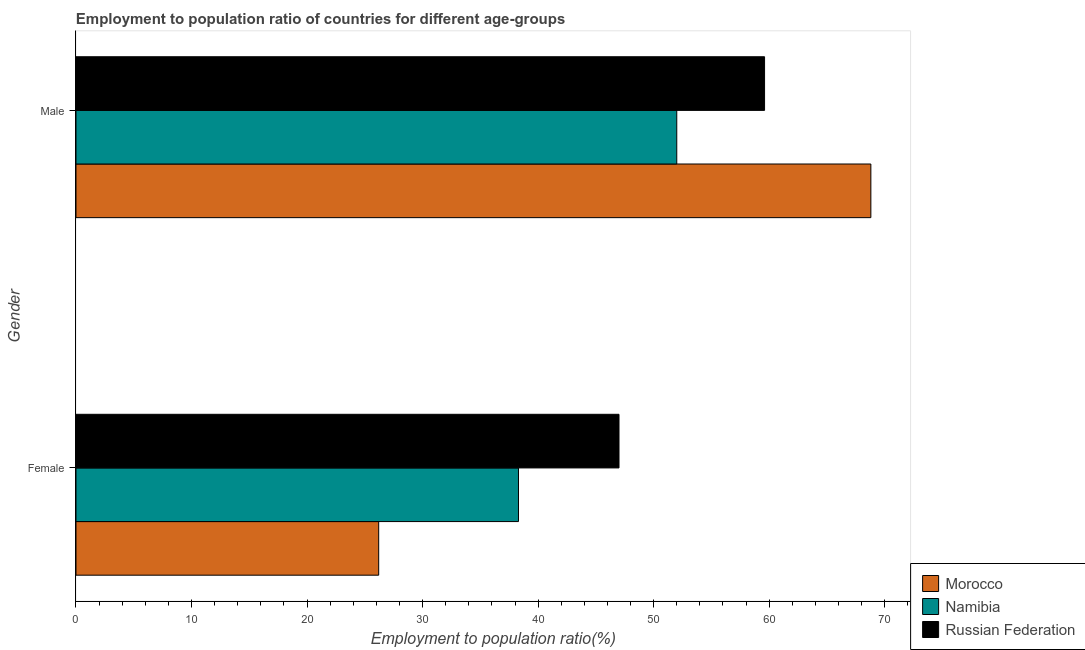How many different coloured bars are there?
Make the answer very short. 3. How many groups of bars are there?
Your answer should be very brief. 2. Are the number of bars per tick equal to the number of legend labels?
Keep it short and to the point. Yes. How many bars are there on the 1st tick from the top?
Provide a short and direct response. 3. How many bars are there on the 1st tick from the bottom?
Keep it short and to the point. 3. Across all countries, what is the maximum employment to population ratio(male)?
Make the answer very short. 68.8. Across all countries, what is the minimum employment to population ratio(female)?
Provide a succinct answer. 26.2. In which country was the employment to population ratio(female) maximum?
Make the answer very short. Russian Federation. In which country was the employment to population ratio(female) minimum?
Offer a terse response. Morocco. What is the total employment to population ratio(male) in the graph?
Provide a short and direct response. 180.4. What is the difference between the employment to population ratio(male) in Russian Federation and that in Namibia?
Make the answer very short. 7.6. What is the difference between the employment to population ratio(female) in Morocco and the employment to population ratio(male) in Russian Federation?
Provide a succinct answer. -33.4. What is the average employment to population ratio(female) per country?
Your response must be concise. 37.17. What is the difference between the employment to population ratio(female) and employment to population ratio(male) in Morocco?
Offer a terse response. -42.6. In how many countries, is the employment to population ratio(male) greater than 32 %?
Keep it short and to the point. 3. What is the ratio of the employment to population ratio(female) in Morocco to that in Namibia?
Offer a very short reply. 0.68. Is the employment to population ratio(female) in Russian Federation less than that in Morocco?
Offer a terse response. No. What does the 1st bar from the top in Female represents?
Your answer should be very brief. Russian Federation. What does the 1st bar from the bottom in Female represents?
Your response must be concise. Morocco. How many countries are there in the graph?
Keep it short and to the point. 3. What is the difference between two consecutive major ticks on the X-axis?
Keep it short and to the point. 10. How are the legend labels stacked?
Make the answer very short. Vertical. What is the title of the graph?
Provide a succinct answer. Employment to population ratio of countries for different age-groups. Does "Nepal" appear as one of the legend labels in the graph?
Make the answer very short. No. What is the Employment to population ratio(%) of Morocco in Female?
Ensure brevity in your answer.  26.2. What is the Employment to population ratio(%) in Namibia in Female?
Your response must be concise. 38.3. What is the Employment to population ratio(%) in Russian Federation in Female?
Ensure brevity in your answer.  47. What is the Employment to population ratio(%) of Morocco in Male?
Provide a succinct answer. 68.8. What is the Employment to population ratio(%) in Russian Federation in Male?
Your answer should be very brief. 59.6. Across all Gender, what is the maximum Employment to population ratio(%) in Morocco?
Your answer should be compact. 68.8. Across all Gender, what is the maximum Employment to population ratio(%) of Russian Federation?
Your answer should be compact. 59.6. Across all Gender, what is the minimum Employment to population ratio(%) in Morocco?
Your answer should be compact. 26.2. Across all Gender, what is the minimum Employment to population ratio(%) in Namibia?
Provide a succinct answer. 38.3. What is the total Employment to population ratio(%) in Morocco in the graph?
Your answer should be compact. 95. What is the total Employment to population ratio(%) in Namibia in the graph?
Offer a very short reply. 90.3. What is the total Employment to population ratio(%) of Russian Federation in the graph?
Provide a short and direct response. 106.6. What is the difference between the Employment to population ratio(%) of Morocco in Female and that in Male?
Your response must be concise. -42.6. What is the difference between the Employment to population ratio(%) in Namibia in Female and that in Male?
Offer a terse response. -13.7. What is the difference between the Employment to population ratio(%) in Russian Federation in Female and that in Male?
Make the answer very short. -12.6. What is the difference between the Employment to population ratio(%) of Morocco in Female and the Employment to population ratio(%) of Namibia in Male?
Give a very brief answer. -25.8. What is the difference between the Employment to population ratio(%) of Morocco in Female and the Employment to population ratio(%) of Russian Federation in Male?
Ensure brevity in your answer.  -33.4. What is the difference between the Employment to population ratio(%) in Namibia in Female and the Employment to population ratio(%) in Russian Federation in Male?
Provide a short and direct response. -21.3. What is the average Employment to population ratio(%) of Morocco per Gender?
Make the answer very short. 47.5. What is the average Employment to population ratio(%) of Namibia per Gender?
Give a very brief answer. 45.15. What is the average Employment to population ratio(%) in Russian Federation per Gender?
Ensure brevity in your answer.  53.3. What is the difference between the Employment to population ratio(%) of Morocco and Employment to population ratio(%) of Namibia in Female?
Offer a very short reply. -12.1. What is the difference between the Employment to population ratio(%) in Morocco and Employment to population ratio(%) in Russian Federation in Female?
Give a very brief answer. -20.8. What is the difference between the Employment to population ratio(%) of Namibia and Employment to population ratio(%) of Russian Federation in Female?
Your response must be concise. -8.7. What is the difference between the Employment to population ratio(%) in Morocco and Employment to population ratio(%) in Namibia in Male?
Provide a succinct answer. 16.8. What is the ratio of the Employment to population ratio(%) in Morocco in Female to that in Male?
Make the answer very short. 0.38. What is the ratio of the Employment to population ratio(%) in Namibia in Female to that in Male?
Your response must be concise. 0.74. What is the ratio of the Employment to population ratio(%) of Russian Federation in Female to that in Male?
Provide a short and direct response. 0.79. What is the difference between the highest and the second highest Employment to population ratio(%) of Morocco?
Offer a very short reply. 42.6. What is the difference between the highest and the second highest Employment to population ratio(%) of Namibia?
Give a very brief answer. 13.7. What is the difference between the highest and the second highest Employment to population ratio(%) of Russian Federation?
Provide a short and direct response. 12.6. What is the difference between the highest and the lowest Employment to population ratio(%) of Morocco?
Make the answer very short. 42.6. 